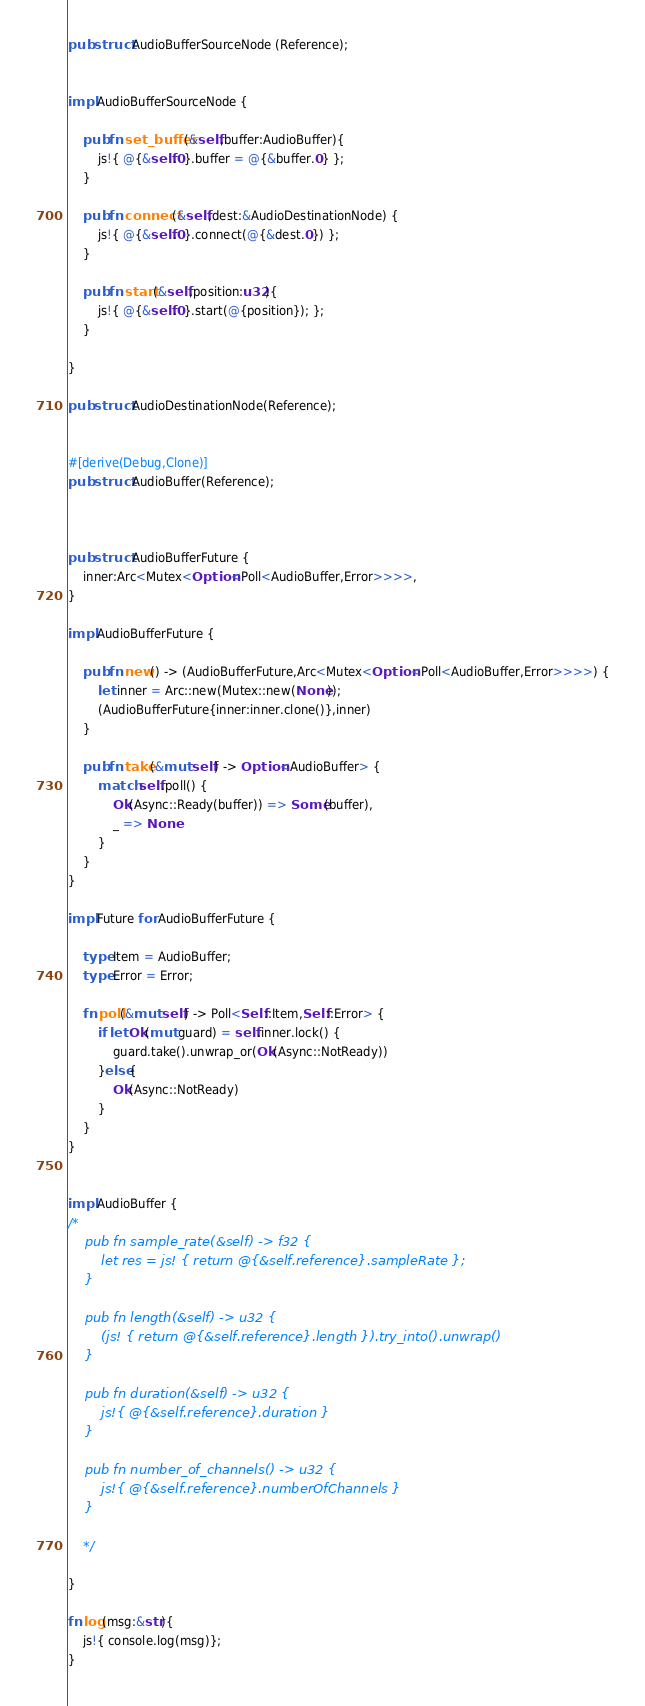Convert code to text. <code><loc_0><loc_0><loc_500><loc_500><_Rust_>
pub struct AudioBufferSourceNode (Reference);


impl AudioBufferSourceNode {

    pub fn set_buffer(&self,buffer:AudioBuffer){
        js!{ @{&self.0}.buffer = @{&buffer.0} };
    }

    pub fn connect(&self,dest:&AudioDestinationNode) {
        js!{ @{&self.0}.connect(@{&dest.0}) };
    }

    pub fn start(&self,position:u32){
        js!{ @{&self.0}.start(@{position}); };
    }

}

pub struct AudioDestinationNode(Reference);


#[derive(Debug,Clone)]
pub struct AudioBuffer(Reference);



pub struct AudioBufferFuture {
    inner:Arc<Mutex<Option<Poll<AudioBuffer,Error>>>>,
}

impl AudioBufferFuture {
    
    pub fn new() -> (AudioBufferFuture,Arc<Mutex<Option<Poll<AudioBuffer,Error>>>>) {
        let inner = Arc::new(Mutex::new(None));
        (AudioBufferFuture{inner:inner.clone()},inner)
    }

    pub fn take(&mut self) -> Option<AudioBuffer> {
        match self.poll() {
            Ok(Async::Ready(buffer)) => Some(buffer),
            _ => None
        }
    }
}

impl Future for AudioBufferFuture {

    type Item = AudioBuffer;
    type Error = Error;

    fn poll(&mut self) -> Poll<Self::Item,Self::Error> {
        if let Ok(mut guard) = self.inner.lock() {
            guard.take().unwrap_or(Ok(Async::NotReady))
        }else{
            Ok(Async::NotReady)
        }
    }
}


impl AudioBuffer {
/*
    pub fn sample_rate(&self) -> f32 {
        let res = js! { return @{&self.reference}.sampleRate };
    }

    pub fn length(&self) -> u32 {
        (js! { return @{&self.reference}.length }).try_into().unwrap()
    }

    pub fn duration(&self) -> u32 {
        js!{ @{&self.reference}.duration }
    }

    pub fn number_of_channels() -> u32 {
        js!{ @{&self.reference}.numberOfChannels }
    }

    */

}

fn log(msg:&str){
    js!{ console.log(msg)};
}</code> 